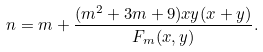<formula> <loc_0><loc_0><loc_500><loc_500>n = m + \frac { ( m ^ { 2 } + 3 m + 9 ) x y ( x + y ) } { F _ { m } ( x , y ) } .</formula> 